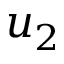Convert formula to latex. <formula><loc_0><loc_0><loc_500><loc_500>u _ { 2 }</formula> 